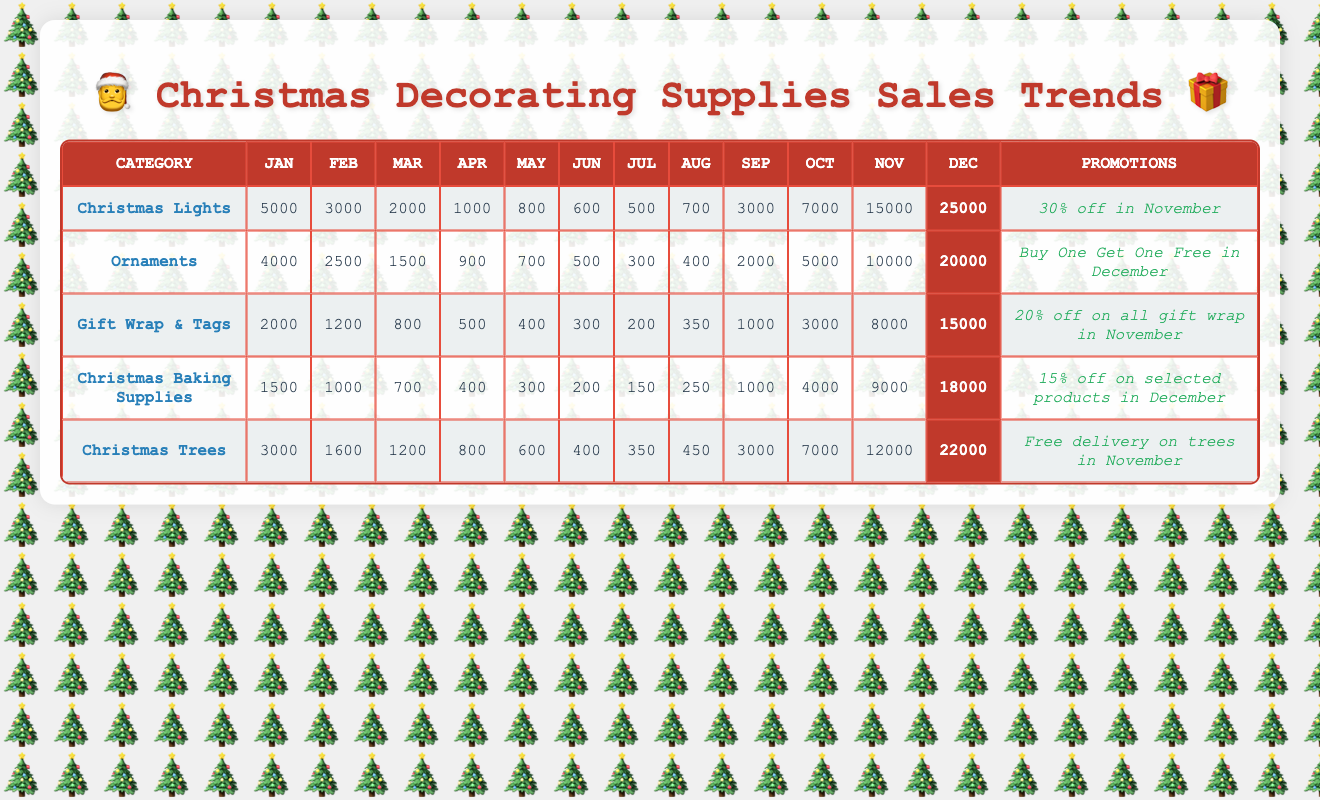What was the total sales for Christmas Lights in December? The sales for Christmas Lights in December are listed in the table as 25000. Therefore, the total sales for this category in December is simply that value.
Answer: 25000 Which category had the highest sales in November? To answer this, we can compare the sales values for November in each category. Christmas Lights have 15000, Ornaments have 10000, Gift Wrap & Tags have 8000, Christmas Baking Supplies have 9000, and Christmas Trees have 12000. The highest value is 15000 from Christmas Lights.
Answer: Christmas Lights What is the average sales figure for Christmas Trees from January to April? We sum the sales for January (3000), February (1600), March (1200), and April (800), which gives 3000 + 1600 + 1200 + 800 = 6600. We then divide that sum by the number of months, which is 4, resulting in an average of 6600 / 4 = 1650.
Answer: 1650 Did Gift Wrap & Tags surpass 10000 in sales any month? Looking at the sales figures for each month in the Gift Wrap & Tags category, we find the values: January (2000), February (1200), March (800), April (500), May (400), June (300), July (200), August (350), September (1000), October (3000), November (8000), and December (15000). The only month that surpasses 10000 is December, where the sales are 15000. Thus, yes, it did.
Answer: Yes What was the percentage increase in sales for Ornaments from November to December? The sales figure for Ornaments in November is 10000 and December is 20000. To find the percentage increase, we first calculate the difference between the two months: 20000 - 10000 = 10000. Then we divide this difference by November's sales: 10000 / 10000 = 1. Finally, we convert it to percentage by multiplying by 100, which gives us 1 * 100 = 100%.
Answer: 100% Which category had the lowest sales in June? The sales figures for June across the categories are as follows: Christmas Lights (600), Ornaments (500), Gift Wrap & Tags (300), Christmas Baking Supplies (200), and Christmas Trees (400). The lowest value is the 200 from Christmas Baking Supplies, which is the smallest figure in June.
Answer: Christmas Baking Supplies What is the total sales for Gift Wrap & Tags for the entire year (all months combined)? To calculate total sales for Gift Wrap & Tags, we sum the values for each month: 2000 + 1200 + 800 + 500 + 400 + 300 + 200 + 350 + 1000 + 3000 + 8000 + 15000 = 30450. Therefore, the total annual sales is 30450.
Answer: 30450 Was there a promotional activity for Christmas Trees in December? The promotional activity listed in the table for Christmas Trees states "Free delivery on trees in November," with no mention of December promotion. Therefore, there was no promotional activity for Christmas Trees in December.
Answer: No 